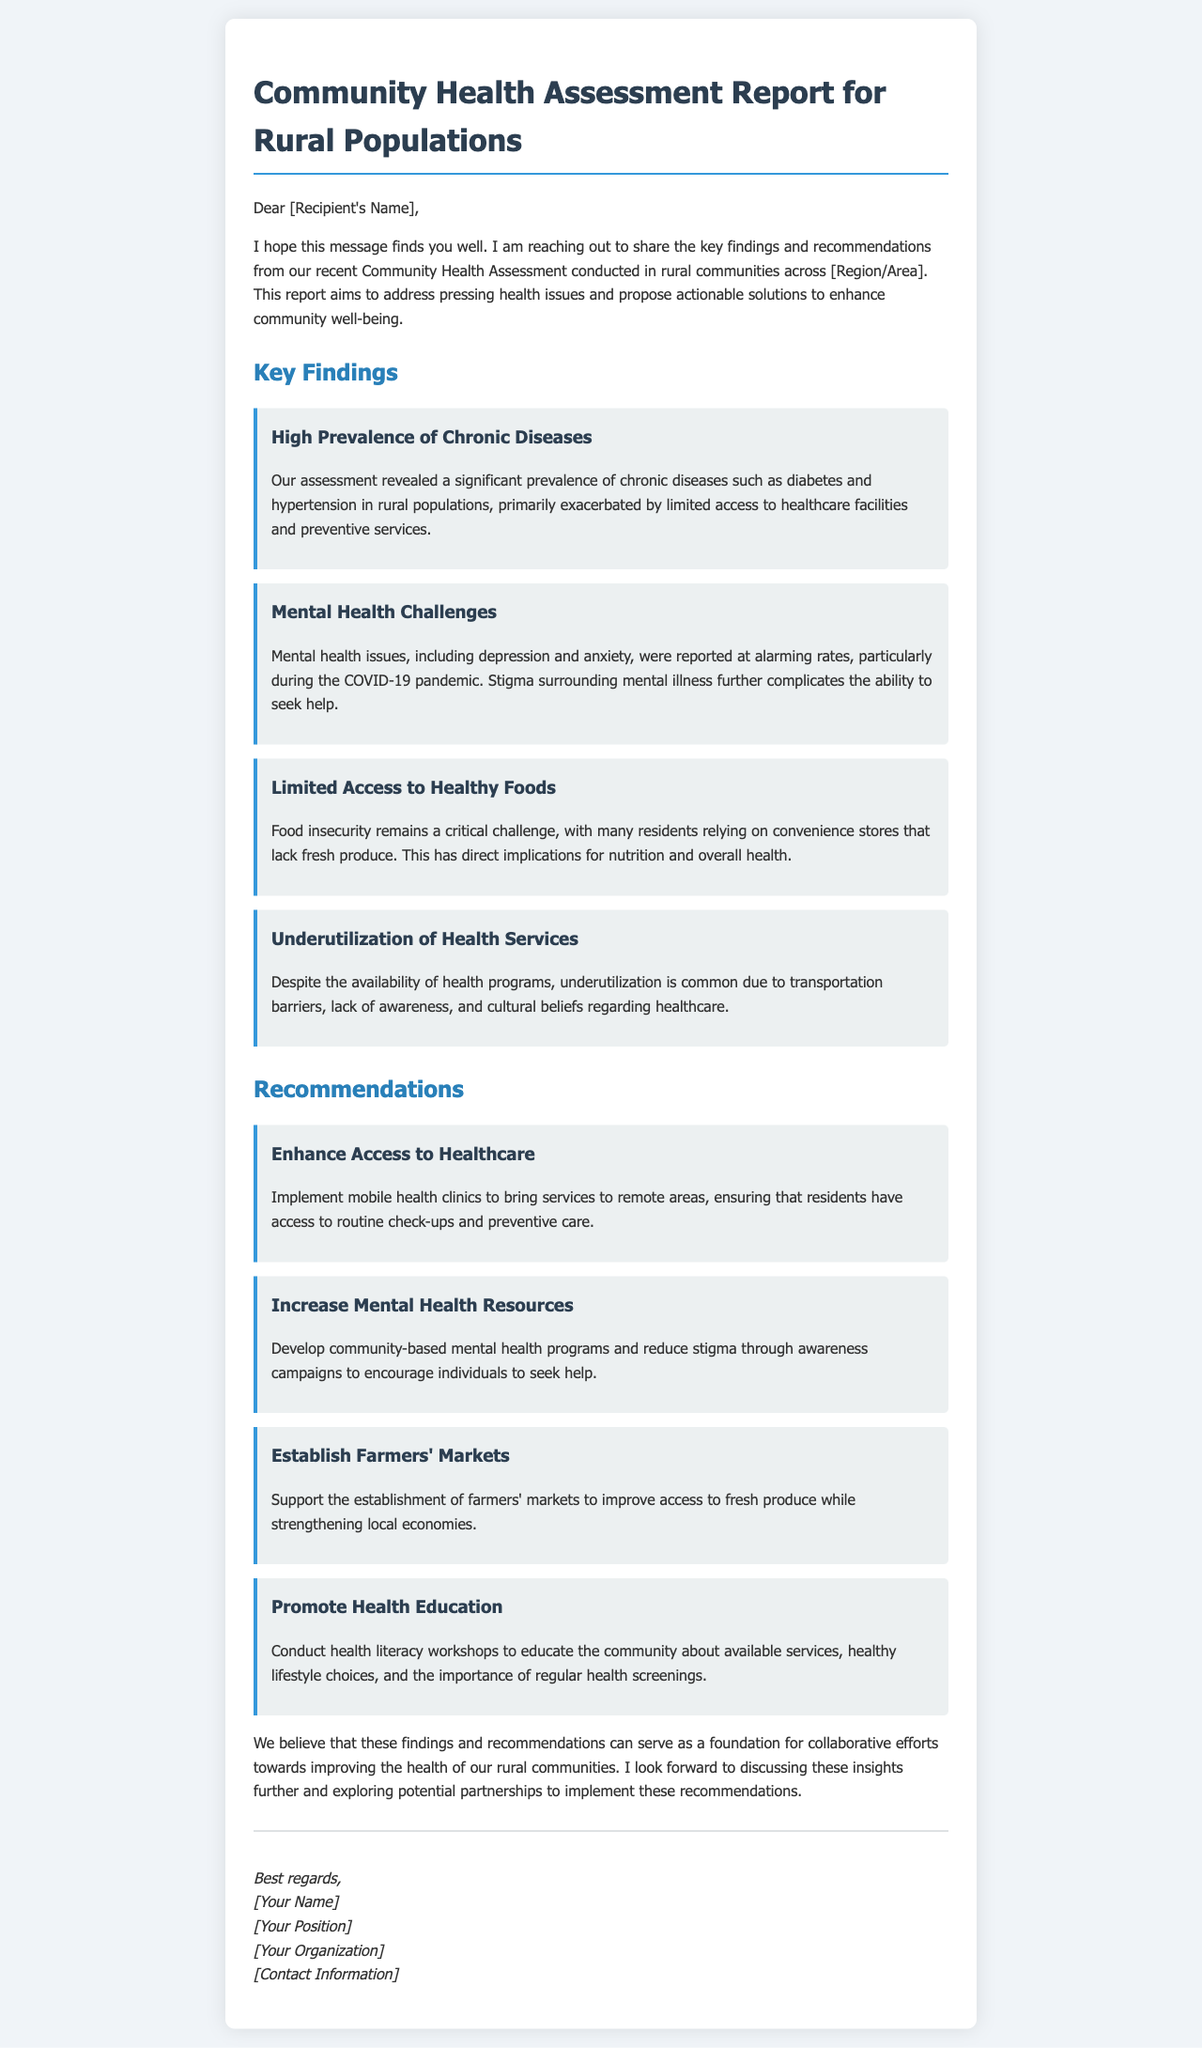What is the main purpose of the report? The report aims to address pressing health issues and propose actionable solutions to enhance community well-being.
Answer: Enhance community well-being What chronic diseases were highlighted in the report? The report mentions significant prevalence of chronic diseases such as diabetes and hypertension.
Answer: Diabetes and hypertension What was reported at alarming rates during the COVID-19 pandemic? The report states mental health issues, including depression and anxiety, were reported at alarming rates.
Answer: Mental health issues What is the recommendation for improving access to fresh produce? The report recommends supporting the establishment of farmers' markets.
Answer: Establish farmers' markets What is one of the barriers to healthcare utilization mentioned? The report lists transportation barriers as one reason for underutilization of health services.
Answer: Transportation barriers What type of programs should be developed for mental health? The report recommends developing community-based mental health programs.
Answer: Community-based mental health programs What should be conducted to promote health education? The report suggests conducting health literacy workshops.
Answer: Health literacy workshops How many key findings are presented in the report? The report includes four key findings related to community health.
Answer: Four findings Who is the sender of the email? The sender is referred to as [Your Name] in the signature.
Answer: [Your Name] 